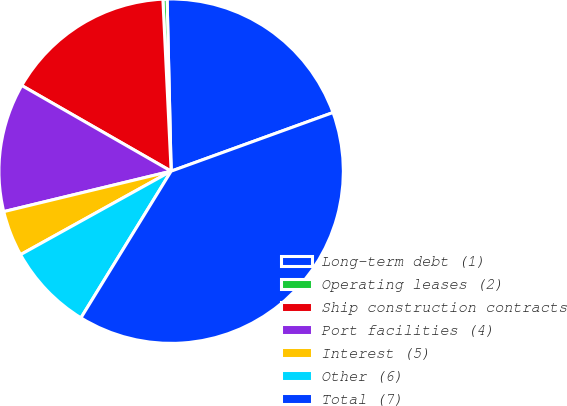Convert chart. <chart><loc_0><loc_0><loc_500><loc_500><pie_chart><fcel>Long-term debt (1)<fcel>Operating leases (2)<fcel>Ship construction contracts<fcel>Port facilities (4)<fcel>Interest (5)<fcel>Other (6)<fcel>Total (7)<nl><fcel>19.84%<fcel>0.39%<fcel>15.95%<fcel>12.06%<fcel>4.28%<fcel>8.17%<fcel>39.3%<nl></chart> 